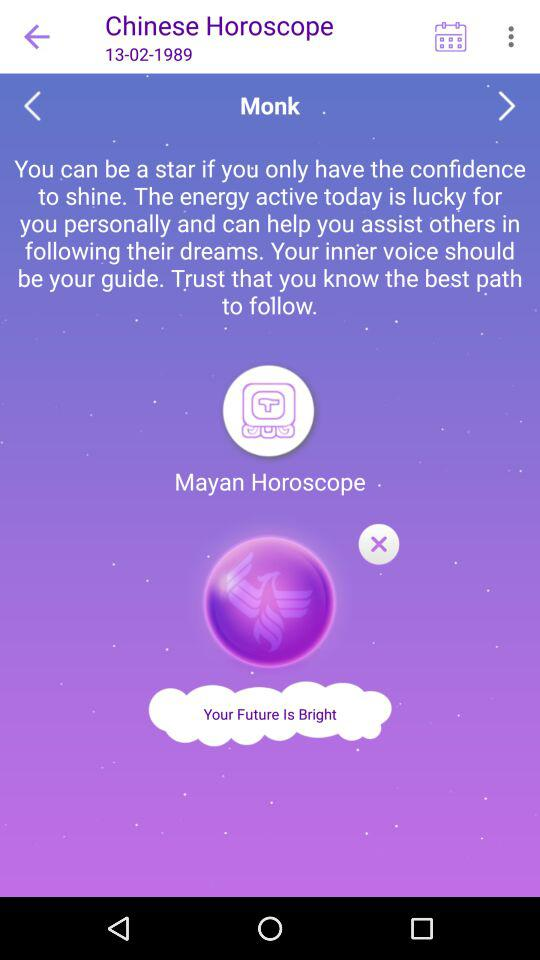What is the date? The date is February 13, 1989. 